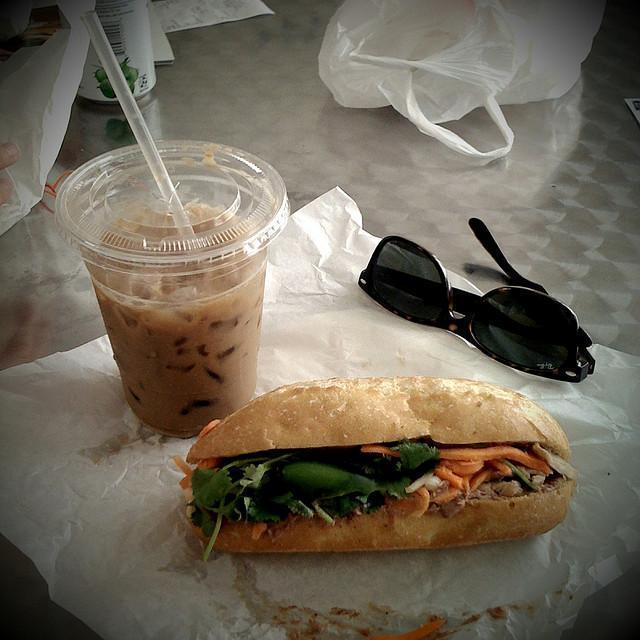Does the image validate the caption "The hot dog is on the dining table."?
Answer yes or no. Yes. Is the caption "The sandwich is on the dining table." a true representation of the image?
Answer yes or no. Yes. 